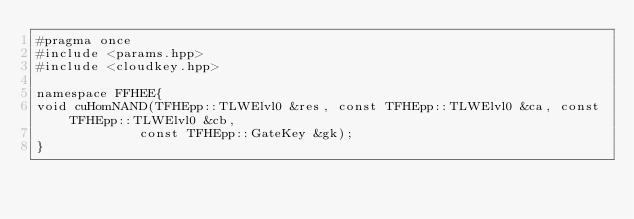Convert code to text. <code><loc_0><loc_0><loc_500><loc_500><_Cuda_>#pragma once
#include <params.hpp>
#include <cloudkey.hpp>

namespace FFHEE{
void cuHomNAND(TFHEpp::TLWElvl0 &res, const TFHEpp::TLWElvl0 &ca, const TFHEpp::TLWElvl0 &cb,
             const TFHEpp::GateKey &gk);
}</code> 